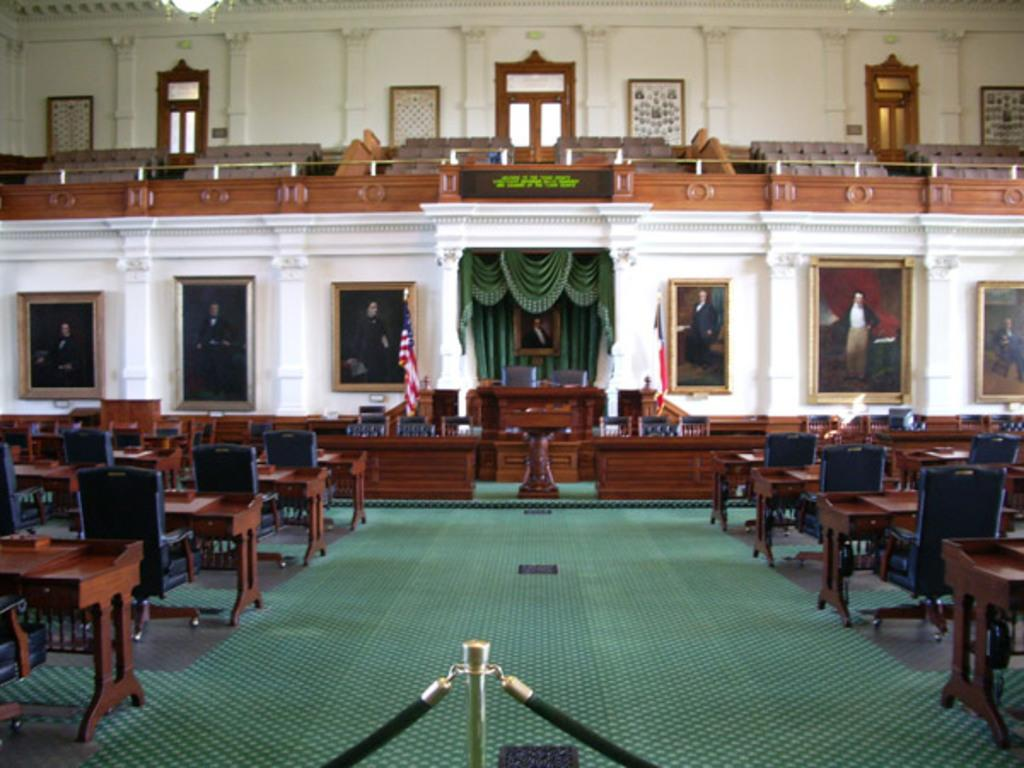What type of floor covering is visible in the image? The floor has a carpet. What can be seen on the wall in the image? There are pictures on the wall. Where are the flags located in the image? The flags are beside a table. What type of furniture is present in the image? Chairs and tables are present. What is located beside the pictures on the wall? Windows are beside the pictures on the wall. What is the current time in the image? There is no indication of time in the image, so it cannot be determined. What type of border is visible in the image? There is no mention of a border in the provided facts, so it cannot be determined. 